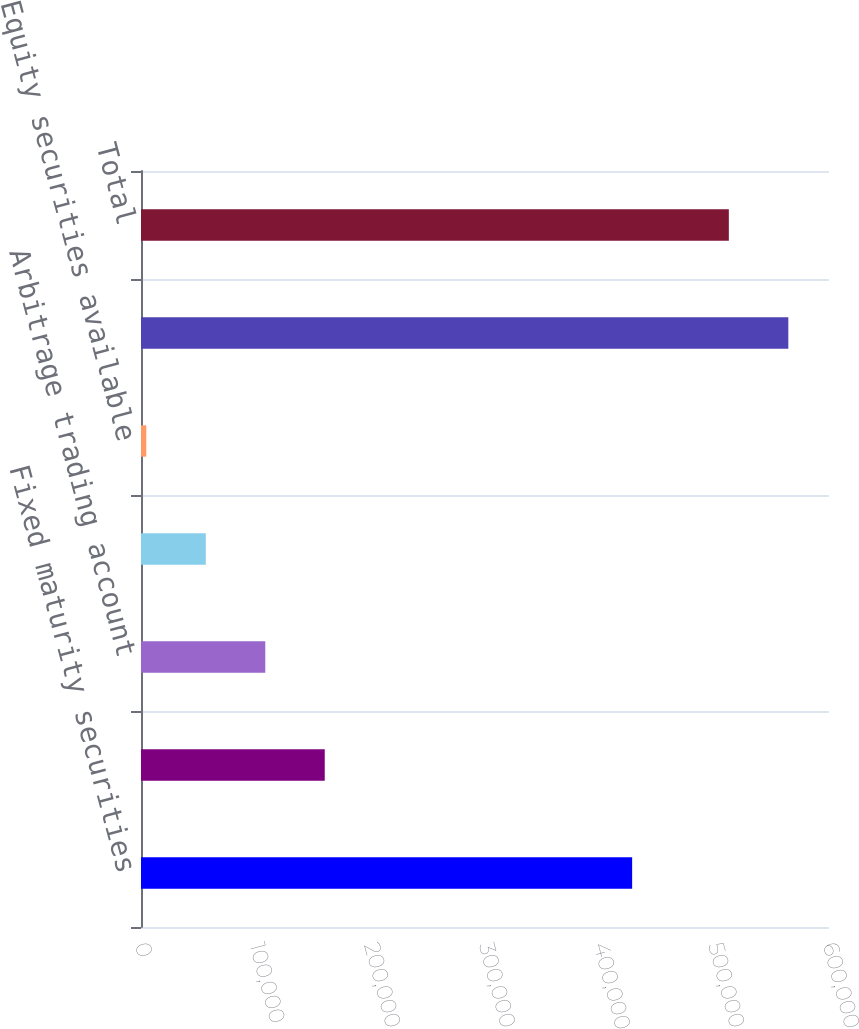Convert chart to OTSL. <chart><loc_0><loc_0><loc_500><loc_500><bar_chart><fcel>Fixed maturity securities<fcel>Investment funds<fcel>Arbitrage trading account<fcel>Real estate<fcel>Equity securities available<fcel>Gross investment income<fcel>Total<nl><fcel>428325<fcel>160245<fcel>108372<fcel>56497.8<fcel>4624<fcel>564519<fcel>512645<nl></chart> 